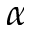<formula> <loc_0><loc_0><loc_500><loc_500>\alpha</formula> 